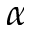<formula> <loc_0><loc_0><loc_500><loc_500>\alpha</formula> 